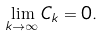Convert formula to latex. <formula><loc_0><loc_0><loc_500><loc_500>\lim _ { k \to \infty } { C _ { k } } = 0 .</formula> 